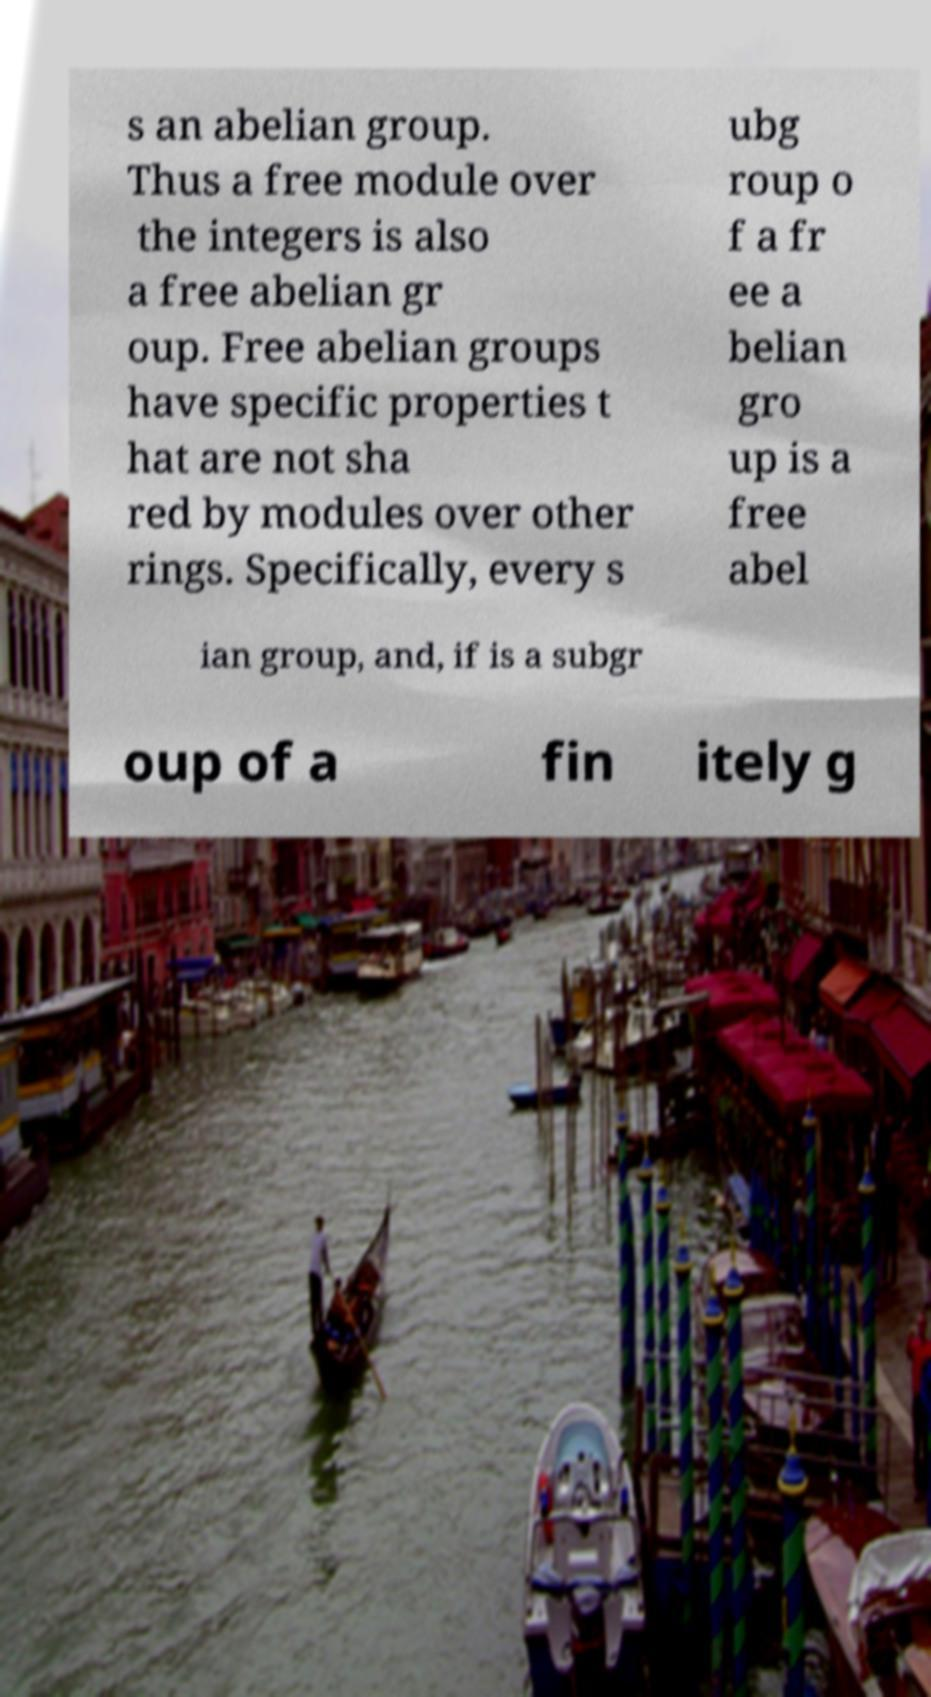For documentation purposes, I need the text within this image transcribed. Could you provide that? s an abelian group. Thus a free module over the integers is also a free abelian gr oup. Free abelian groups have specific properties t hat are not sha red by modules over other rings. Specifically, every s ubg roup o f a fr ee a belian gro up is a free abel ian group, and, if is a subgr oup of a fin itely g 